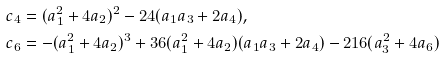<formula> <loc_0><loc_0><loc_500><loc_500>c _ { 4 } & = ( a _ { 1 } ^ { 2 } + 4 a _ { 2 } ) ^ { 2 } - 2 4 ( a _ { 1 } a _ { 3 } + 2 a _ { 4 } ) , \\ c _ { 6 } & = - ( a _ { 1 } ^ { 2 } + 4 a _ { 2 } ) ^ { 3 } + 3 6 ( a _ { 1 } ^ { 2 } + 4 a _ { 2 } ) ( a _ { 1 } a _ { 3 } + 2 a _ { 4 } ) - 2 1 6 ( a _ { 3 } ^ { 2 } + 4 a _ { 6 } )</formula> 